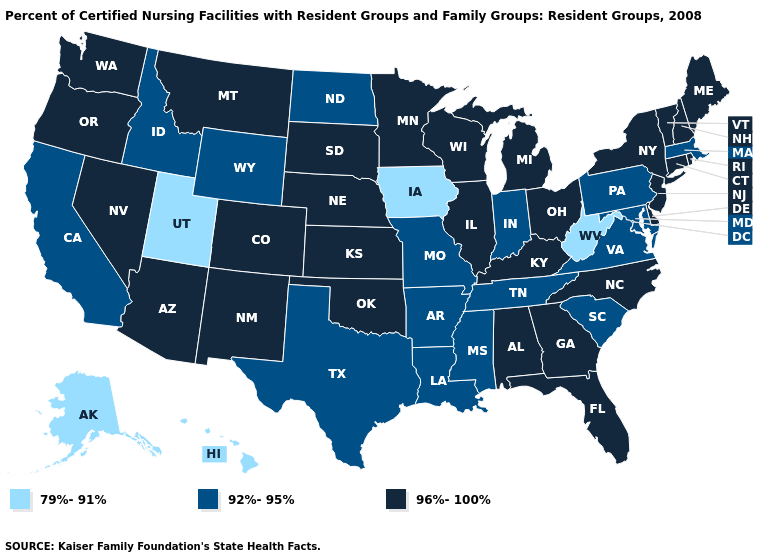What is the highest value in states that border West Virginia?
Concise answer only. 96%-100%. What is the lowest value in the West?
Keep it brief. 79%-91%. Does Pennsylvania have the same value as Maine?
Short answer required. No. What is the value of New Mexico?
Give a very brief answer. 96%-100%. Does Pennsylvania have the highest value in the Northeast?
Write a very short answer. No. What is the value of Colorado?
Answer briefly. 96%-100%. Name the states that have a value in the range 79%-91%?
Write a very short answer. Alaska, Hawaii, Iowa, Utah, West Virginia. Name the states that have a value in the range 96%-100%?
Keep it brief. Alabama, Arizona, Colorado, Connecticut, Delaware, Florida, Georgia, Illinois, Kansas, Kentucky, Maine, Michigan, Minnesota, Montana, Nebraska, Nevada, New Hampshire, New Jersey, New Mexico, New York, North Carolina, Ohio, Oklahoma, Oregon, Rhode Island, South Dakota, Vermont, Washington, Wisconsin. Is the legend a continuous bar?
Answer briefly. No. Does Louisiana have a lower value than Arizona?
Concise answer only. Yes. Name the states that have a value in the range 79%-91%?
Give a very brief answer. Alaska, Hawaii, Iowa, Utah, West Virginia. Name the states that have a value in the range 96%-100%?
Quick response, please. Alabama, Arizona, Colorado, Connecticut, Delaware, Florida, Georgia, Illinois, Kansas, Kentucky, Maine, Michigan, Minnesota, Montana, Nebraska, Nevada, New Hampshire, New Jersey, New Mexico, New York, North Carolina, Ohio, Oklahoma, Oregon, Rhode Island, South Dakota, Vermont, Washington, Wisconsin. What is the value of Utah?
Write a very short answer. 79%-91%. Does the map have missing data?
Be succinct. No. 